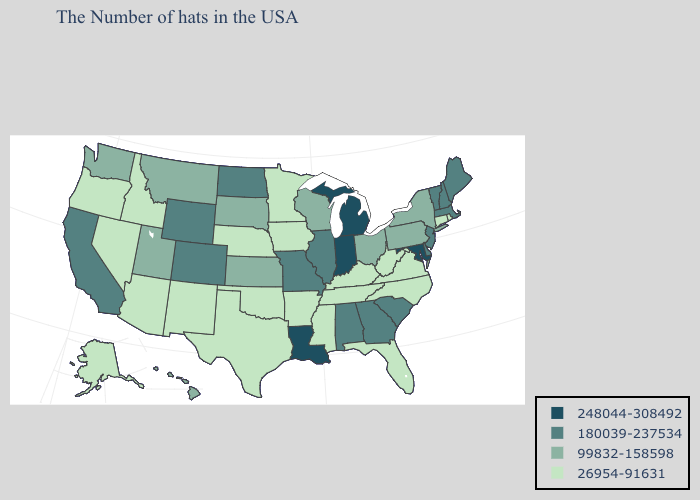What is the value of Maine?
Concise answer only. 180039-237534. What is the value of Utah?
Quick response, please. 99832-158598. What is the value of Colorado?
Keep it brief. 180039-237534. Among the states that border Nebraska , does South Dakota have the highest value?
Write a very short answer. No. What is the lowest value in states that border North Dakota?
Write a very short answer. 26954-91631. Which states have the lowest value in the Northeast?
Answer briefly. Rhode Island, Connecticut. Name the states that have a value in the range 99832-158598?
Short answer required. New York, Pennsylvania, Ohio, Wisconsin, Kansas, South Dakota, Utah, Montana, Washington, Hawaii. Does Delaware have a higher value than Illinois?
Short answer required. No. Name the states that have a value in the range 248044-308492?
Concise answer only. Maryland, Michigan, Indiana, Louisiana. Does South Dakota have the lowest value in the MidWest?
Give a very brief answer. No. What is the value of Virginia?
Be succinct. 26954-91631. Which states have the lowest value in the MidWest?
Short answer required. Minnesota, Iowa, Nebraska. Does South Carolina have the highest value in the South?
Concise answer only. No. Which states hav the highest value in the Northeast?
Short answer required. Maine, Massachusetts, New Hampshire, Vermont, New Jersey. 